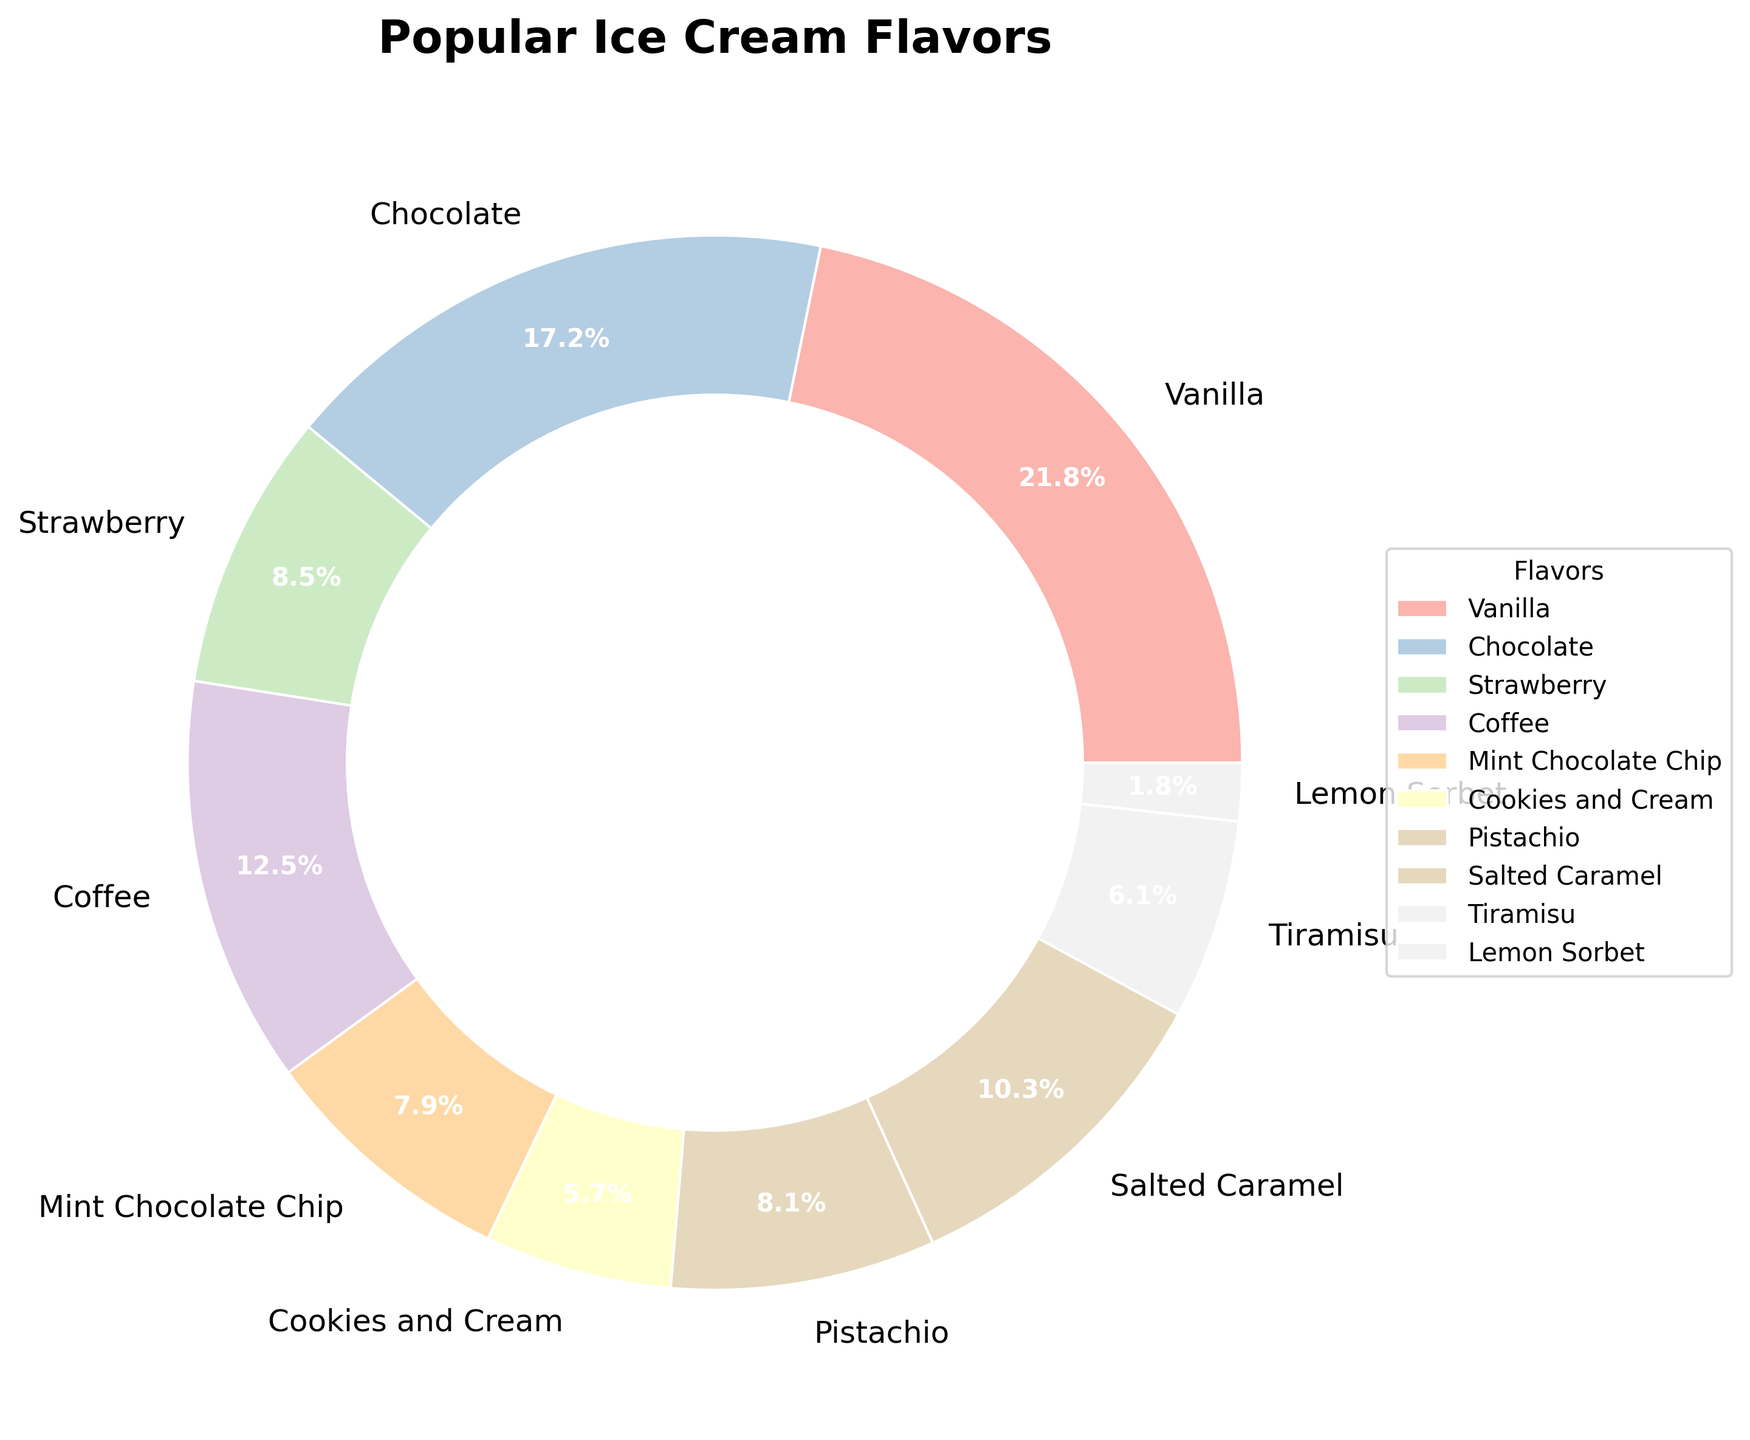What's the most popular ice cream flavor overall? You can see in the pie chart that the largest wedge represents Vanilla.
Answer: Vanilla Which age group prefers Coffee flavor the most? By looking at the chart, the wedge corresponding to Coffee and the labels, the highest percentage of Coffee is consumed by the 18-24 age group.
Answer: 18-24 How does the popularity of Salted Caramel vary with age? Observe the size of the wedges corresponding to Salted Caramel: it increases from 7 in 18-24 to 15 in 55+, indicating the flavor's popularity grows as age increases.
Answer: Increases with age What's the combined percentage share of Vanilla and Chocolate flavors? Look at the chart to see Vanilla (largest slice at 110) and Chocolate (85). Combine the percentages: 110 + 85 = 195.
Answer: 195% Which flavor has nearly equal popularity across multiple age groups? View the chart and note the wedges for Coffee, which has similar size wedges comparatively across different age groups (18-24 to 55+).
Answer: Coffee Are older customers (55+) more inclined towards traditional or unique flavors? Observing the wedges for 55+ closely, we see larger slices for traditional flavors such as Vanilla, Pistachio, and less for unique flavors like Lemon Sorbet.
Answer: Traditional flavors What's the difference in popularity between the most popular and the least popular flavor? Vanilla has the highest percentage (the largest wedge), and Lemon Sorbet the lowest (the smallest wedge). Difference = 110 - 9 = 101.
Answer: 101% How does the preference for Strawberry change as the age group increases? The wedges for Strawberry consistently decrease from 18-24 (12) to 55+ (6), indicating a declining trend with age.
Answer: Decreasing Which two flavors together make up more than 25% of the total? Examine the chart: combining Vanilla (highest at 110) and Chocolate (second at 85) easily surpasses 25%.
Answer: Vanilla and Chocolate 